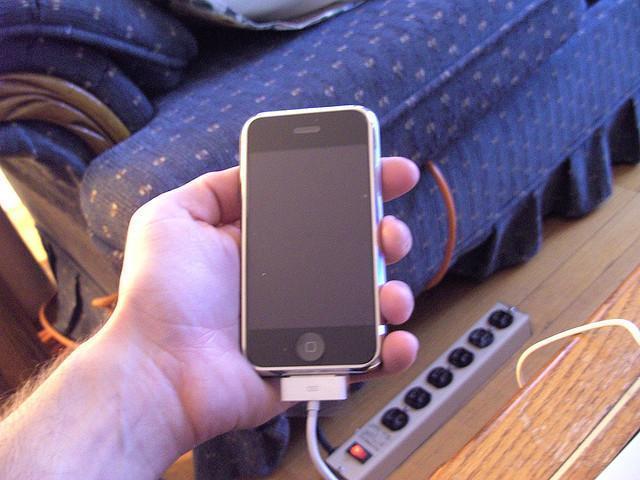Is the statement "The couch is in front of the person." accurate regarding the image?
Answer yes or no. Yes. 